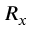<formula> <loc_0><loc_0><loc_500><loc_500>R _ { x }</formula> 